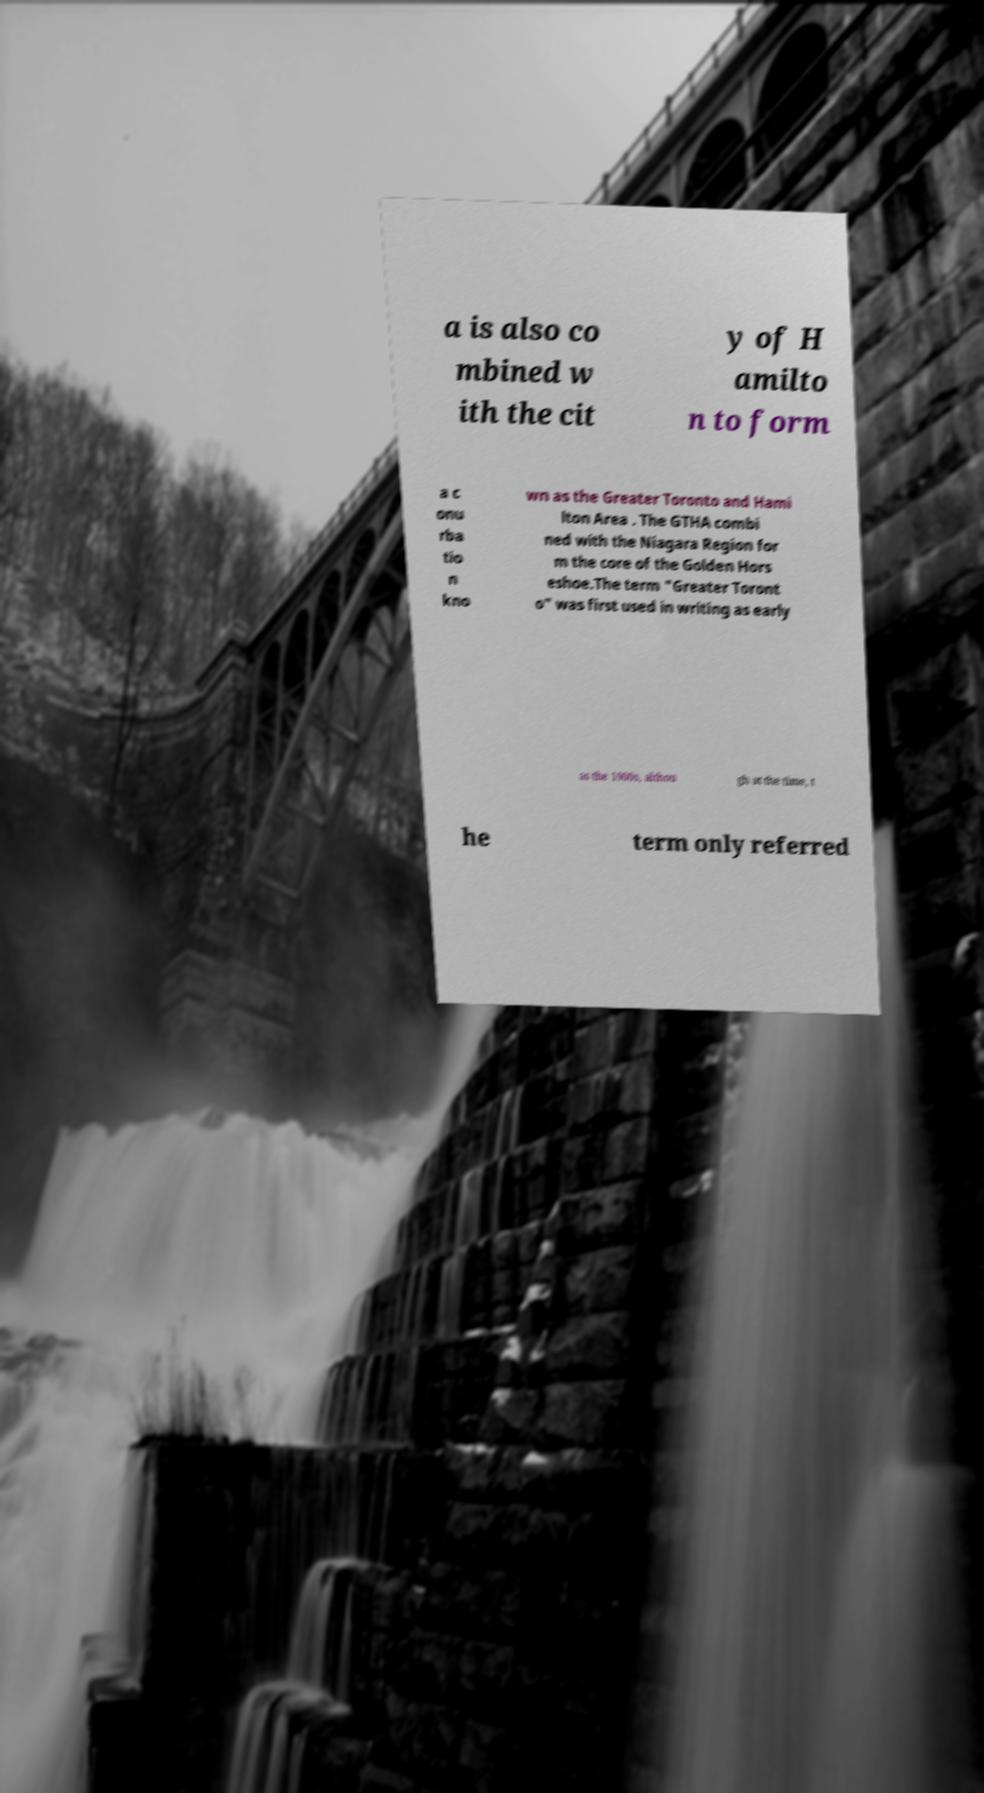For documentation purposes, I need the text within this image transcribed. Could you provide that? a is also co mbined w ith the cit y of H amilto n to form a c onu rba tio n kno wn as the Greater Toronto and Hami lton Area . The GTHA combi ned with the Niagara Region for m the core of the Golden Hors eshoe.The term "Greater Toront o" was first used in writing as early as the 1900s, althou gh at the time, t he term only referred 